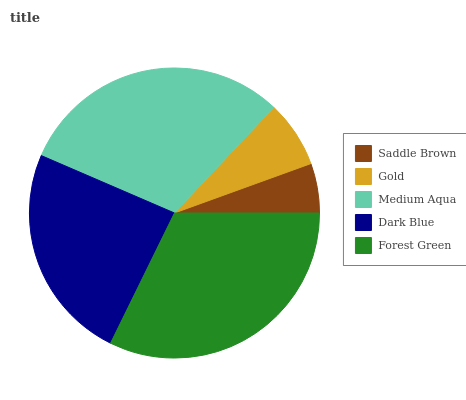Is Saddle Brown the minimum?
Answer yes or no. Yes. Is Forest Green the maximum?
Answer yes or no. Yes. Is Gold the minimum?
Answer yes or no. No. Is Gold the maximum?
Answer yes or no. No. Is Gold greater than Saddle Brown?
Answer yes or no. Yes. Is Saddle Brown less than Gold?
Answer yes or no. Yes. Is Saddle Brown greater than Gold?
Answer yes or no. No. Is Gold less than Saddle Brown?
Answer yes or no. No. Is Dark Blue the high median?
Answer yes or no. Yes. Is Dark Blue the low median?
Answer yes or no. Yes. Is Gold the high median?
Answer yes or no. No. Is Saddle Brown the low median?
Answer yes or no. No. 